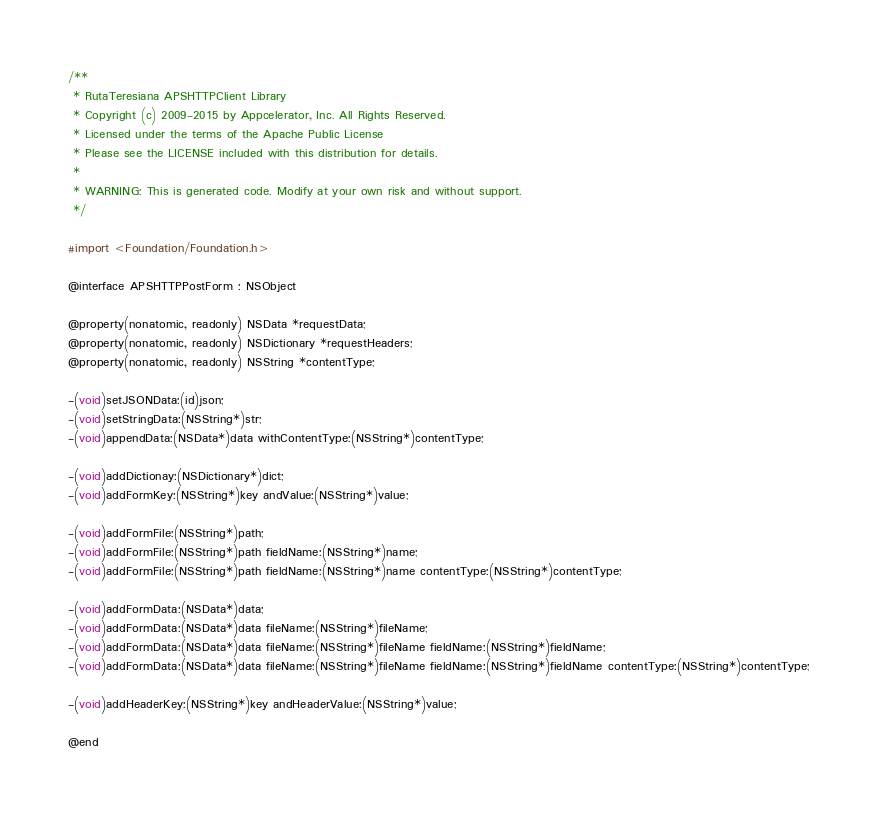Convert code to text. <code><loc_0><loc_0><loc_500><loc_500><_C_>/**
 * RutaTeresiana APSHTTPClient Library
 * Copyright (c) 2009-2015 by Appcelerator, Inc. All Rights Reserved.
 * Licensed under the terms of the Apache Public License
 * Please see the LICENSE included with this distribution for details.
 * 
 * WARNING: This is generated code. Modify at your own risk and without support.
 */

#import <Foundation/Foundation.h>

@interface APSHTTPPostForm : NSObject

@property(nonatomic, readonly) NSData *requestData;
@property(nonatomic, readonly) NSDictionary *requestHeaders;
@property(nonatomic, readonly) NSString *contentType;

-(void)setJSONData:(id)json;
-(void)setStringData:(NSString*)str;
-(void)appendData:(NSData*)data withContentType:(NSString*)contentType;

-(void)addDictionay:(NSDictionary*)dict;
-(void)addFormKey:(NSString*)key andValue:(NSString*)value;

-(void)addFormFile:(NSString*)path;
-(void)addFormFile:(NSString*)path fieldName:(NSString*)name;
-(void)addFormFile:(NSString*)path fieldName:(NSString*)name contentType:(NSString*)contentType;

-(void)addFormData:(NSData*)data;
-(void)addFormData:(NSData*)data fileName:(NSString*)fileName;
-(void)addFormData:(NSData*)data fileName:(NSString*)fileName fieldName:(NSString*)fieldName;
-(void)addFormData:(NSData*)data fileName:(NSString*)fileName fieldName:(NSString*)fieldName contentType:(NSString*)contentType;

-(void)addHeaderKey:(NSString*)key andHeaderValue:(NSString*)value;

@end
</code> 